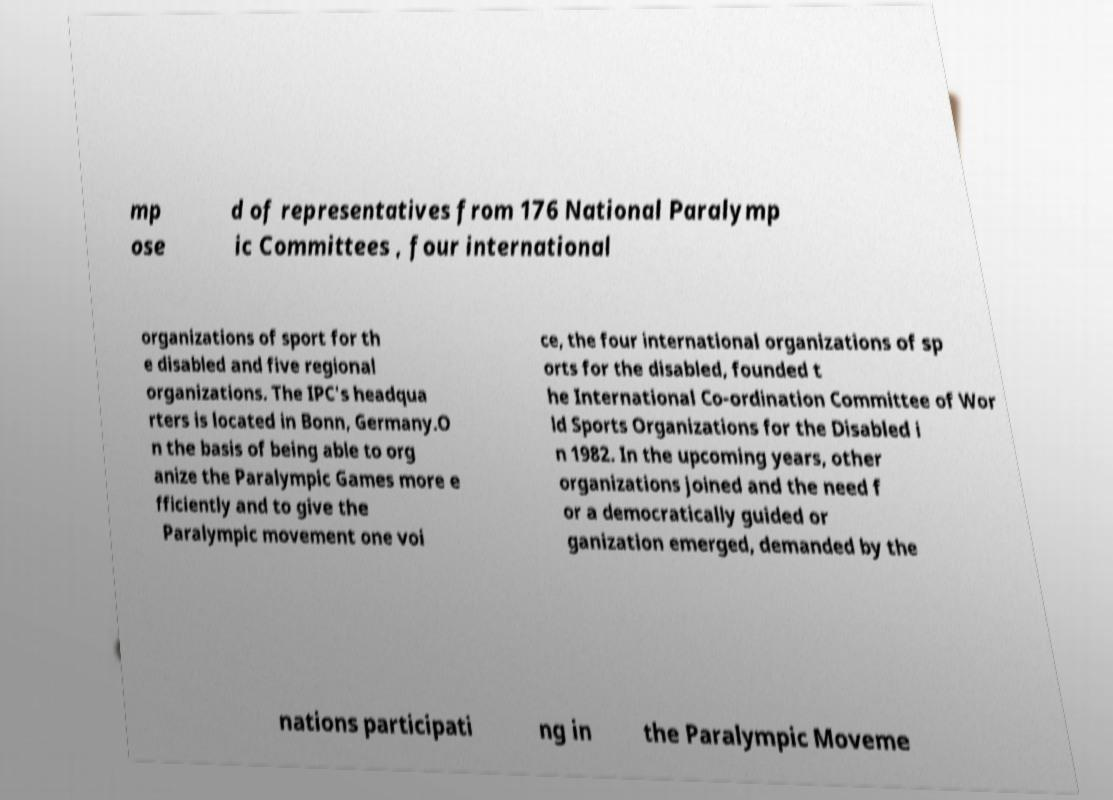Please identify and transcribe the text found in this image. mp ose d of representatives from 176 National Paralymp ic Committees , four international organizations of sport for th e disabled and five regional organizations. The IPC's headqua rters is located in Bonn, Germany.O n the basis of being able to org anize the Paralympic Games more e fficiently and to give the Paralympic movement one voi ce, the four international organizations of sp orts for the disabled, founded t he International Co-ordination Committee of Wor ld Sports Organizations for the Disabled i n 1982. In the upcoming years, other organizations joined and the need f or a democratically guided or ganization emerged, demanded by the nations participati ng in the Paralympic Moveme 